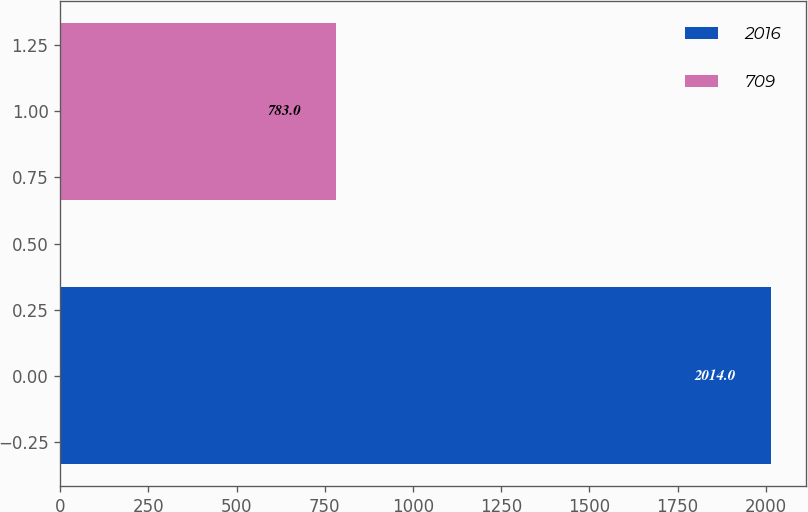Convert chart. <chart><loc_0><loc_0><loc_500><loc_500><bar_chart><fcel>2016<fcel>709<nl><fcel>2014<fcel>783<nl></chart> 